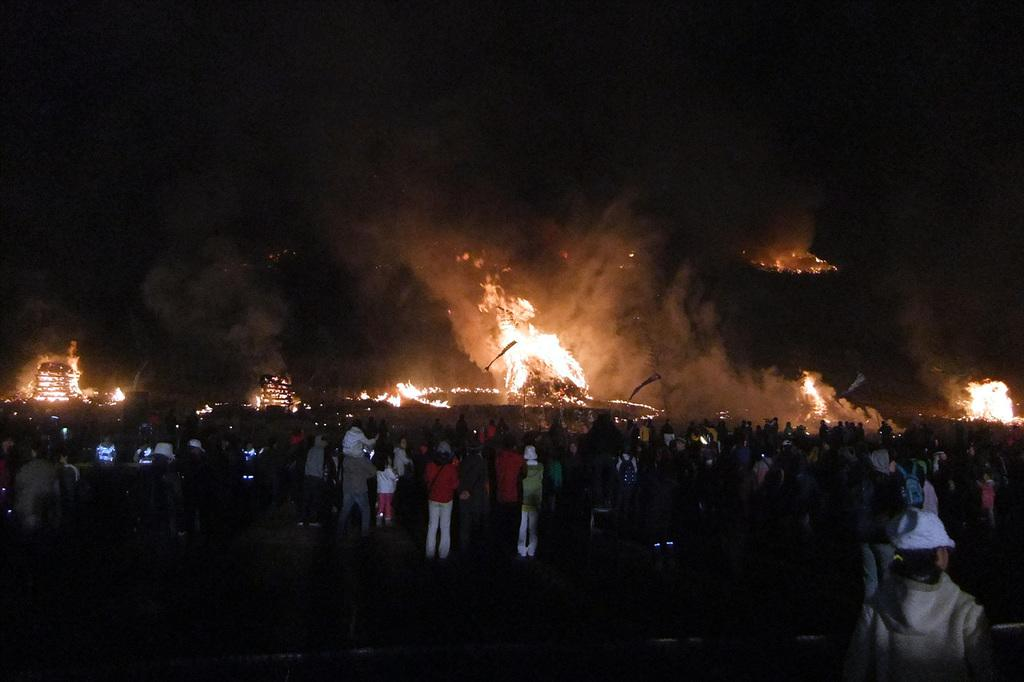What is the main subject of the image? There are people in the center of the image. What can be seen in the background of the image? There is fire in the background of the image. What is visible at the top of the image? The sky is visible at the top of the image. What sound can be heard coming from the people in the image? There is no sound present in the image, as it is a still photograph. 